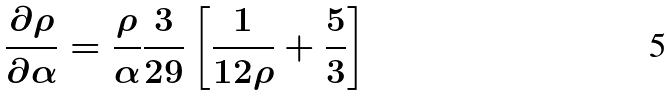<formula> <loc_0><loc_0><loc_500><loc_500>\frac { \partial \rho } { \partial \alpha } = \frac { \rho } { \alpha } \frac { 3 } { 2 9 } \left [ \frac { 1 } { 1 2 \rho } + \frac { 5 } { 3 } \right ]</formula> 